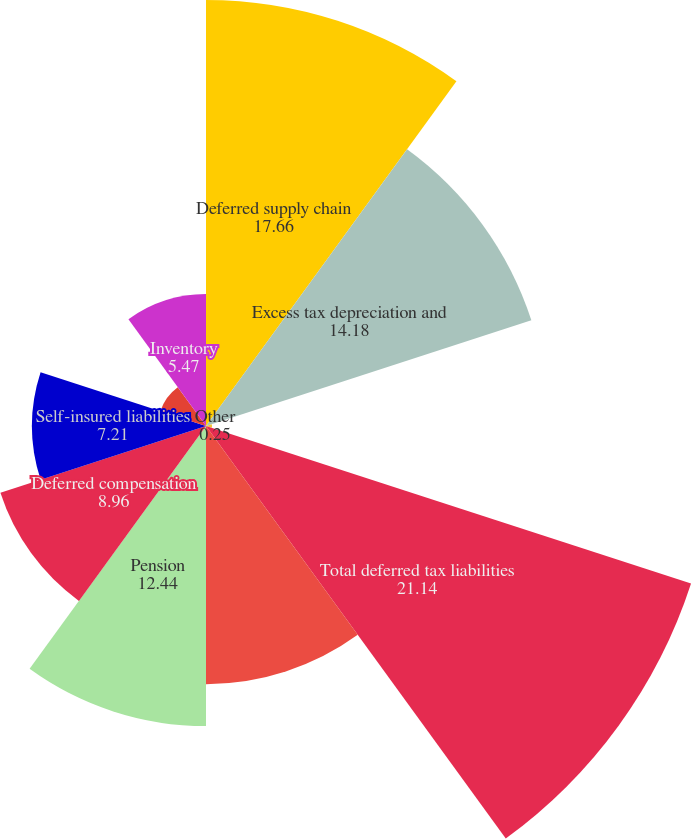Convert chart. <chart><loc_0><loc_0><loc_500><loc_500><pie_chart><fcel>Deferred supply chain<fcel>Excess tax depreciation and<fcel>Other<fcel>Total deferred tax liabilities<fcel>Net operating tax loss<fcel>Pension<fcel>Deferred compensation<fcel>Self-insured liabilities<fcel>Receivables<fcel>Inventory<nl><fcel>17.66%<fcel>14.18%<fcel>0.25%<fcel>21.14%<fcel>10.7%<fcel>12.44%<fcel>8.96%<fcel>7.21%<fcel>1.99%<fcel>5.47%<nl></chart> 